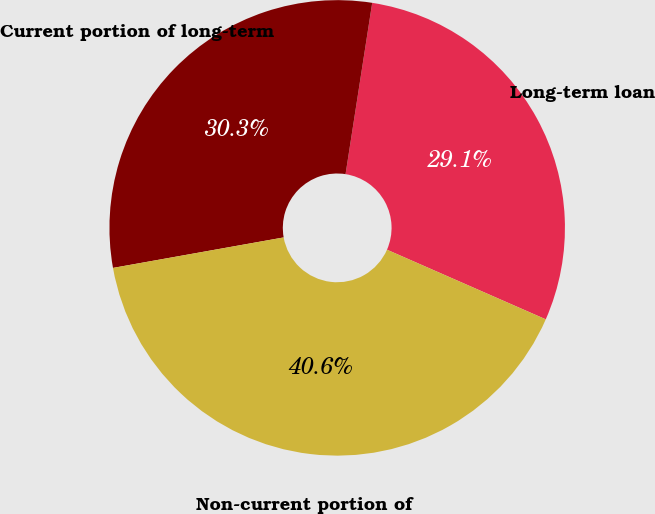<chart> <loc_0><loc_0><loc_500><loc_500><pie_chart><fcel>Long-term loan<fcel>Current portion of long-term<fcel>Non-current portion of<nl><fcel>29.12%<fcel>30.27%<fcel>40.61%<nl></chart> 